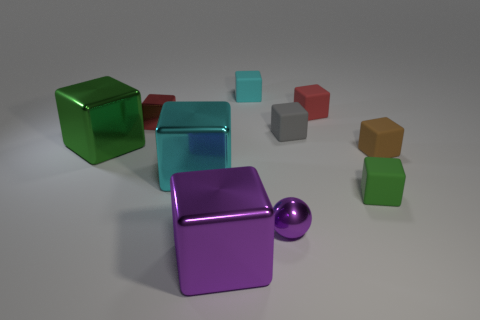What is the shape of the cyan object that is behind the red object that is on the left side of the tiny purple metal sphere?
Provide a short and direct response. Cube. The gray matte object has what size?
Offer a very short reply. Small. The big green shiny object is what shape?
Provide a succinct answer. Cube. There is a small gray matte object; is its shape the same as the green object behind the tiny brown thing?
Provide a short and direct response. Yes. There is a purple object to the right of the big purple metal thing; is it the same shape as the big cyan shiny object?
Offer a terse response. No. How many things are both right of the small purple metal sphere and in front of the ball?
Your response must be concise. 0. How many other objects are there of the same size as the brown cube?
Make the answer very short. 6. Are there an equal number of small green blocks that are to the left of the small metal cube and tiny things?
Provide a short and direct response. No. There is a big object right of the cyan metallic thing; is its color the same as the tiny shiny thing that is behind the tiny green thing?
Keep it short and to the point. No. What material is the cube that is both right of the small red metal cube and on the left side of the large purple thing?
Offer a very short reply. Metal. 